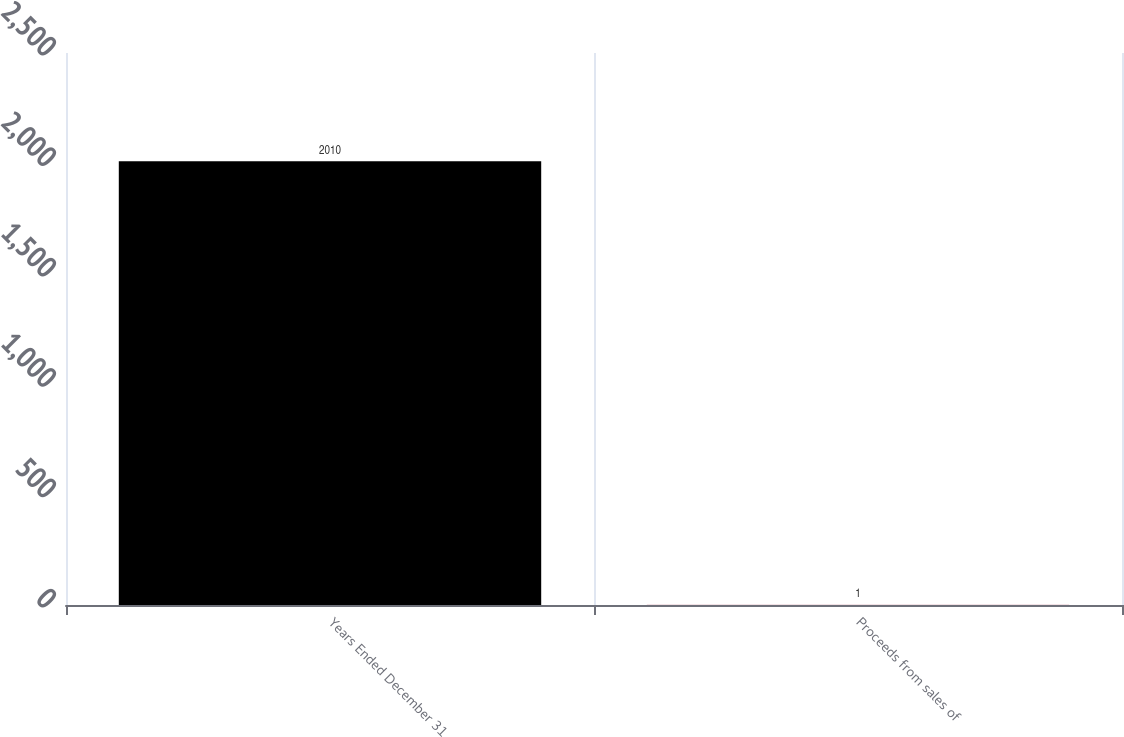Convert chart to OTSL. <chart><loc_0><loc_0><loc_500><loc_500><bar_chart><fcel>Years Ended December 31<fcel>Proceeds from sales of<nl><fcel>2010<fcel>1<nl></chart> 